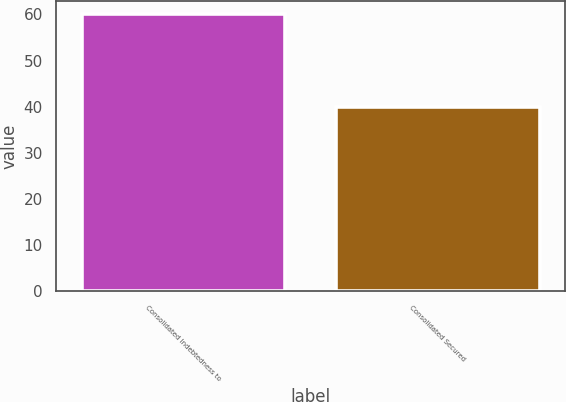Convert chart to OTSL. <chart><loc_0><loc_0><loc_500><loc_500><bar_chart><fcel>Consolidated Indebtedness to<fcel>Consolidated Secured<nl><fcel>60<fcel>40<nl></chart> 